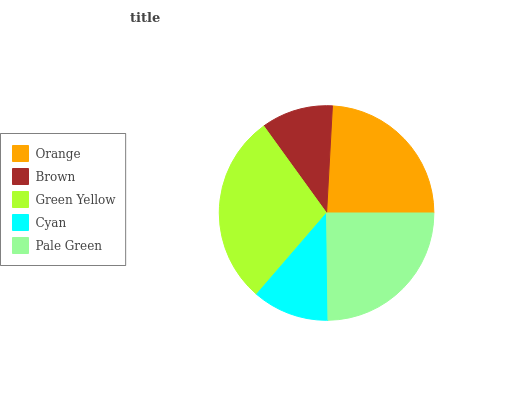Is Brown the minimum?
Answer yes or no. Yes. Is Green Yellow the maximum?
Answer yes or no. Yes. Is Green Yellow the minimum?
Answer yes or no. No. Is Brown the maximum?
Answer yes or no. No. Is Green Yellow greater than Brown?
Answer yes or no. Yes. Is Brown less than Green Yellow?
Answer yes or no. Yes. Is Brown greater than Green Yellow?
Answer yes or no. No. Is Green Yellow less than Brown?
Answer yes or no. No. Is Orange the high median?
Answer yes or no. Yes. Is Orange the low median?
Answer yes or no. Yes. Is Brown the high median?
Answer yes or no. No. Is Cyan the low median?
Answer yes or no. No. 